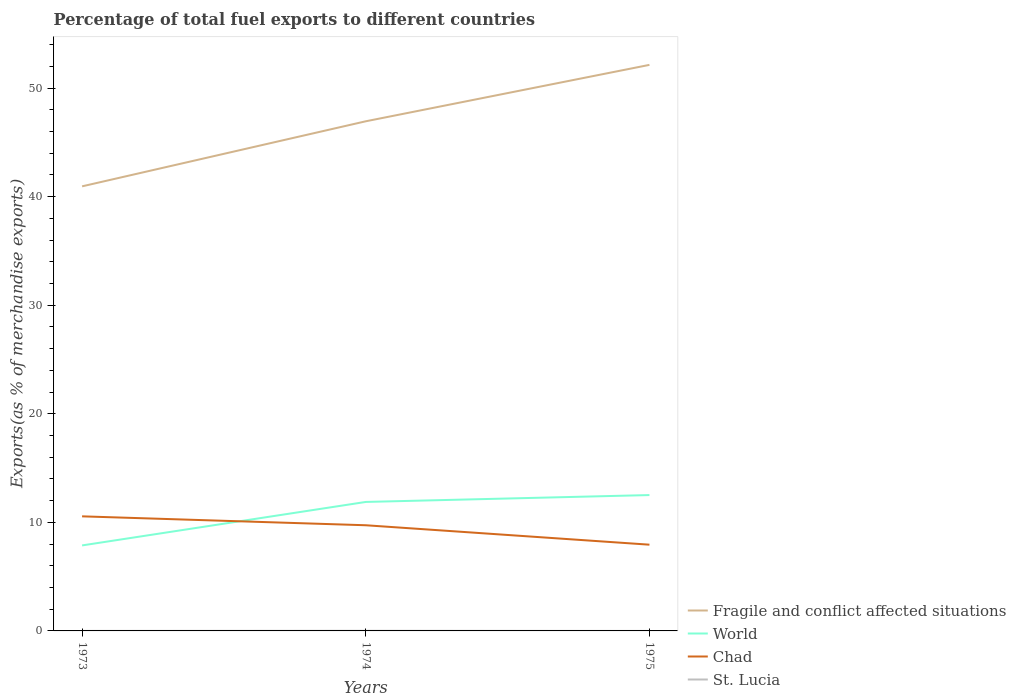Across all years, what is the maximum percentage of exports to different countries in St. Lucia?
Offer a very short reply. 0. What is the total percentage of exports to different countries in Fragile and conflict affected situations in the graph?
Keep it short and to the point. -5.2. What is the difference between the highest and the second highest percentage of exports to different countries in St. Lucia?
Provide a short and direct response. 0.01. What is the difference between the highest and the lowest percentage of exports to different countries in Fragile and conflict affected situations?
Give a very brief answer. 2. Is the percentage of exports to different countries in World strictly greater than the percentage of exports to different countries in Fragile and conflict affected situations over the years?
Offer a very short reply. Yes. How many years are there in the graph?
Keep it short and to the point. 3. Does the graph contain any zero values?
Ensure brevity in your answer.  No. How are the legend labels stacked?
Your answer should be compact. Vertical. What is the title of the graph?
Your answer should be compact. Percentage of total fuel exports to different countries. What is the label or title of the X-axis?
Keep it short and to the point. Years. What is the label or title of the Y-axis?
Make the answer very short. Exports(as % of merchandise exports). What is the Exports(as % of merchandise exports) in Fragile and conflict affected situations in 1973?
Your response must be concise. 40.95. What is the Exports(as % of merchandise exports) in World in 1973?
Make the answer very short. 7.87. What is the Exports(as % of merchandise exports) of Chad in 1973?
Keep it short and to the point. 10.55. What is the Exports(as % of merchandise exports) of St. Lucia in 1973?
Keep it short and to the point. 0. What is the Exports(as % of merchandise exports) in Fragile and conflict affected situations in 1974?
Ensure brevity in your answer.  46.94. What is the Exports(as % of merchandise exports) of World in 1974?
Keep it short and to the point. 11.88. What is the Exports(as % of merchandise exports) in Chad in 1974?
Provide a succinct answer. 9.73. What is the Exports(as % of merchandise exports) in St. Lucia in 1974?
Ensure brevity in your answer.  0.01. What is the Exports(as % of merchandise exports) of Fragile and conflict affected situations in 1975?
Keep it short and to the point. 52.14. What is the Exports(as % of merchandise exports) of World in 1975?
Ensure brevity in your answer.  12.51. What is the Exports(as % of merchandise exports) in Chad in 1975?
Ensure brevity in your answer.  7.94. What is the Exports(as % of merchandise exports) in St. Lucia in 1975?
Your answer should be compact. 0. Across all years, what is the maximum Exports(as % of merchandise exports) in Fragile and conflict affected situations?
Provide a short and direct response. 52.14. Across all years, what is the maximum Exports(as % of merchandise exports) of World?
Keep it short and to the point. 12.51. Across all years, what is the maximum Exports(as % of merchandise exports) of Chad?
Ensure brevity in your answer.  10.55. Across all years, what is the maximum Exports(as % of merchandise exports) in St. Lucia?
Offer a very short reply. 0.01. Across all years, what is the minimum Exports(as % of merchandise exports) in Fragile and conflict affected situations?
Your answer should be compact. 40.95. Across all years, what is the minimum Exports(as % of merchandise exports) in World?
Offer a very short reply. 7.87. Across all years, what is the minimum Exports(as % of merchandise exports) of Chad?
Keep it short and to the point. 7.94. Across all years, what is the minimum Exports(as % of merchandise exports) of St. Lucia?
Your response must be concise. 0. What is the total Exports(as % of merchandise exports) of Fragile and conflict affected situations in the graph?
Ensure brevity in your answer.  140.02. What is the total Exports(as % of merchandise exports) of World in the graph?
Offer a terse response. 32.27. What is the total Exports(as % of merchandise exports) in Chad in the graph?
Offer a terse response. 28.23. What is the total Exports(as % of merchandise exports) of St. Lucia in the graph?
Your response must be concise. 0.02. What is the difference between the Exports(as % of merchandise exports) in Fragile and conflict affected situations in 1973 and that in 1974?
Offer a terse response. -5.99. What is the difference between the Exports(as % of merchandise exports) in World in 1973 and that in 1974?
Provide a succinct answer. -4. What is the difference between the Exports(as % of merchandise exports) in Chad in 1973 and that in 1974?
Ensure brevity in your answer.  0.82. What is the difference between the Exports(as % of merchandise exports) of St. Lucia in 1973 and that in 1974?
Ensure brevity in your answer.  -0.01. What is the difference between the Exports(as % of merchandise exports) in Fragile and conflict affected situations in 1973 and that in 1975?
Make the answer very short. -11.19. What is the difference between the Exports(as % of merchandise exports) of World in 1973 and that in 1975?
Offer a terse response. -4.64. What is the difference between the Exports(as % of merchandise exports) in Chad in 1973 and that in 1975?
Ensure brevity in your answer.  2.61. What is the difference between the Exports(as % of merchandise exports) of St. Lucia in 1973 and that in 1975?
Give a very brief answer. 0. What is the difference between the Exports(as % of merchandise exports) in Fragile and conflict affected situations in 1974 and that in 1975?
Your answer should be very brief. -5.2. What is the difference between the Exports(as % of merchandise exports) of World in 1974 and that in 1975?
Your answer should be compact. -0.63. What is the difference between the Exports(as % of merchandise exports) in Chad in 1974 and that in 1975?
Ensure brevity in your answer.  1.79. What is the difference between the Exports(as % of merchandise exports) in St. Lucia in 1974 and that in 1975?
Provide a succinct answer. 0.01. What is the difference between the Exports(as % of merchandise exports) of Fragile and conflict affected situations in 1973 and the Exports(as % of merchandise exports) of World in 1974?
Your response must be concise. 29.07. What is the difference between the Exports(as % of merchandise exports) of Fragile and conflict affected situations in 1973 and the Exports(as % of merchandise exports) of Chad in 1974?
Your response must be concise. 31.22. What is the difference between the Exports(as % of merchandise exports) of Fragile and conflict affected situations in 1973 and the Exports(as % of merchandise exports) of St. Lucia in 1974?
Provide a succinct answer. 40.94. What is the difference between the Exports(as % of merchandise exports) of World in 1973 and the Exports(as % of merchandise exports) of Chad in 1974?
Your response must be concise. -1.86. What is the difference between the Exports(as % of merchandise exports) in World in 1973 and the Exports(as % of merchandise exports) in St. Lucia in 1974?
Your response must be concise. 7.86. What is the difference between the Exports(as % of merchandise exports) in Chad in 1973 and the Exports(as % of merchandise exports) in St. Lucia in 1974?
Provide a short and direct response. 10.54. What is the difference between the Exports(as % of merchandise exports) of Fragile and conflict affected situations in 1973 and the Exports(as % of merchandise exports) of World in 1975?
Your answer should be compact. 28.43. What is the difference between the Exports(as % of merchandise exports) of Fragile and conflict affected situations in 1973 and the Exports(as % of merchandise exports) of Chad in 1975?
Your answer should be compact. 33. What is the difference between the Exports(as % of merchandise exports) of Fragile and conflict affected situations in 1973 and the Exports(as % of merchandise exports) of St. Lucia in 1975?
Your answer should be very brief. 40.95. What is the difference between the Exports(as % of merchandise exports) in World in 1973 and the Exports(as % of merchandise exports) in Chad in 1975?
Your answer should be compact. -0.07. What is the difference between the Exports(as % of merchandise exports) of World in 1973 and the Exports(as % of merchandise exports) of St. Lucia in 1975?
Offer a very short reply. 7.87. What is the difference between the Exports(as % of merchandise exports) of Chad in 1973 and the Exports(as % of merchandise exports) of St. Lucia in 1975?
Keep it short and to the point. 10.55. What is the difference between the Exports(as % of merchandise exports) of Fragile and conflict affected situations in 1974 and the Exports(as % of merchandise exports) of World in 1975?
Your answer should be compact. 34.43. What is the difference between the Exports(as % of merchandise exports) of Fragile and conflict affected situations in 1974 and the Exports(as % of merchandise exports) of Chad in 1975?
Offer a terse response. 39. What is the difference between the Exports(as % of merchandise exports) of Fragile and conflict affected situations in 1974 and the Exports(as % of merchandise exports) of St. Lucia in 1975?
Provide a succinct answer. 46.94. What is the difference between the Exports(as % of merchandise exports) of World in 1974 and the Exports(as % of merchandise exports) of Chad in 1975?
Your answer should be very brief. 3.94. What is the difference between the Exports(as % of merchandise exports) of World in 1974 and the Exports(as % of merchandise exports) of St. Lucia in 1975?
Offer a very short reply. 11.88. What is the difference between the Exports(as % of merchandise exports) in Chad in 1974 and the Exports(as % of merchandise exports) in St. Lucia in 1975?
Offer a very short reply. 9.73. What is the average Exports(as % of merchandise exports) of Fragile and conflict affected situations per year?
Offer a very short reply. 46.67. What is the average Exports(as % of merchandise exports) in World per year?
Your answer should be very brief. 10.76. What is the average Exports(as % of merchandise exports) of Chad per year?
Ensure brevity in your answer.  9.41. What is the average Exports(as % of merchandise exports) in St. Lucia per year?
Provide a short and direct response. 0.01. In the year 1973, what is the difference between the Exports(as % of merchandise exports) of Fragile and conflict affected situations and Exports(as % of merchandise exports) of World?
Give a very brief answer. 33.07. In the year 1973, what is the difference between the Exports(as % of merchandise exports) of Fragile and conflict affected situations and Exports(as % of merchandise exports) of Chad?
Keep it short and to the point. 30.39. In the year 1973, what is the difference between the Exports(as % of merchandise exports) of Fragile and conflict affected situations and Exports(as % of merchandise exports) of St. Lucia?
Offer a very short reply. 40.94. In the year 1973, what is the difference between the Exports(as % of merchandise exports) in World and Exports(as % of merchandise exports) in Chad?
Keep it short and to the point. -2.68. In the year 1973, what is the difference between the Exports(as % of merchandise exports) of World and Exports(as % of merchandise exports) of St. Lucia?
Keep it short and to the point. 7.87. In the year 1973, what is the difference between the Exports(as % of merchandise exports) of Chad and Exports(as % of merchandise exports) of St. Lucia?
Your answer should be very brief. 10.55. In the year 1974, what is the difference between the Exports(as % of merchandise exports) of Fragile and conflict affected situations and Exports(as % of merchandise exports) of World?
Provide a short and direct response. 35.06. In the year 1974, what is the difference between the Exports(as % of merchandise exports) in Fragile and conflict affected situations and Exports(as % of merchandise exports) in Chad?
Offer a very short reply. 37.21. In the year 1974, what is the difference between the Exports(as % of merchandise exports) of Fragile and conflict affected situations and Exports(as % of merchandise exports) of St. Lucia?
Provide a succinct answer. 46.93. In the year 1974, what is the difference between the Exports(as % of merchandise exports) in World and Exports(as % of merchandise exports) in Chad?
Give a very brief answer. 2.15. In the year 1974, what is the difference between the Exports(as % of merchandise exports) in World and Exports(as % of merchandise exports) in St. Lucia?
Your response must be concise. 11.87. In the year 1974, what is the difference between the Exports(as % of merchandise exports) of Chad and Exports(as % of merchandise exports) of St. Lucia?
Give a very brief answer. 9.72. In the year 1975, what is the difference between the Exports(as % of merchandise exports) in Fragile and conflict affected situations and Exports(as % of merchandise exports) in World?
Offer a terse response. 39.62. In the year 1975, what is the difference between the Exports(as % of merchandise exports) in Fragile and conflict affected situations and Exports(as % of merchandise exports) in Chad?
Ensure brevity in your answer.  44.19. In the year 1975, what is the difference between the Exports(as % of merchandise exports) of Fragile and conflict affected situations and Exports(as % of merchandise exports) of St. Lucia?
Provide a short and direct response. 52.14. In the year 1975, what is the difference between the Exports(as % of merchandise exports) of World and Exports(as % of merchandise exports) of Chad?
Your answer should be very brief. 4.57. In the year 1975, what is the difference between the Exports(as % of merchandise exports) in World and Exports(as % of merchandise exports) in St. Lucia?
Provide a short and direct response. 12.51. In the year 1975, what is the difference between the Exports(as % of merchandise exports) of Chad and Exports(as % of merchandise exports) of St. Lucia?
Provide a succinct answer. 7.94. What is the ratio of the Exports(as % of merchandise exports) in Fragile and conflict affected situations in 1973 to that in 1974?
Provide a succinct answer. 0.87. What is the ratio of the Exports(as % of merchandise exports) of World in 1973 to that in 1974?
Ensure brevity in your answer.  0.66. What is the ratio of the Exports(as % of merchandise exports) of Chad in 1973 to that in 1974?
Your answer should be very brief. 1.08. What is the ratio of the Exports(as % of merchandise exports) of St. Lucia in 1973 to that in 1974?
Ensure brevity in your answer.  0.24. What is the ratio of the Exports(as % of merchandise exports) of Fragile and conflict affected situations in 1973 to that in 1975?
Offer a terse response. 0.79. What is the ratio of the Exports(as % of merchandise exports) of World in 1973 to that in 1975?
Your response must be concise. 0.63. What is the ratio of the Exports(as % of merchandise exports) of Chad in 1973 to that in 1975?
Ensure brevity in your answer.  1.33. What is the ratio of the Exports(as % of merchandise exports) of St. Lucia in 1973 to that in 1975?
Provide a short and direct response. 13.69. What is the ratio of the Exports(as % of merchandise exports) of Fragile and conflict affected situations in 1974 to that in 1975?
Give a very brief answer. 0.9. What is the ratio of the Exports(as % of merchandise exports) in World in 1974 to that in 1975?
Your answer should be compact. 0.95. What is the ratio of the Exports(as % of merchandise exports) in Chad in 1974 to that in 1975?
Offer a very short reply. 1.23. What is the ratio of the Exports(as % of merchandise exports) of St. Lucia in 1974 to that in 1975?
Your answer should be compact. 56.41. What is the difference between the highest and the second highest Exports(as % of merchandise exports) of Fragile and conflict affected situations?
Offer a very short reply. 5.2. What is the difference between the highest and the second highest Exports(as % of merchandise exports) of World?
Offer a very short reply. 0.63. What is the difference between the highest and the second highest Exports(as % of merchandise exports) in Chad?
Keep it short and to the point. 0.82. What is the difference between the highest and the second highest Exports(as % of merchandise exports) in St. Lucia?
Ensure brevity in your answer.  0.01. What is the difference between the highest and the lowest Exports(as % of merchandise exports) of Fragile and conflict affected situations?
Make the answer very short. 11.19. What is the difference between the highest and the lowest Exports(as % of merchandise exports) in World?
Ensure brevity in your answer.  4.64. What is the difference between the highest and the lowest Exports(as % of merchandise exports) in Chad?
Give a very brief answer. 2.61. What is the difference between the highest and the lowest Exports(as % of merchandise exports) in St. Lucia?
Offer a terse response. 0.01. 